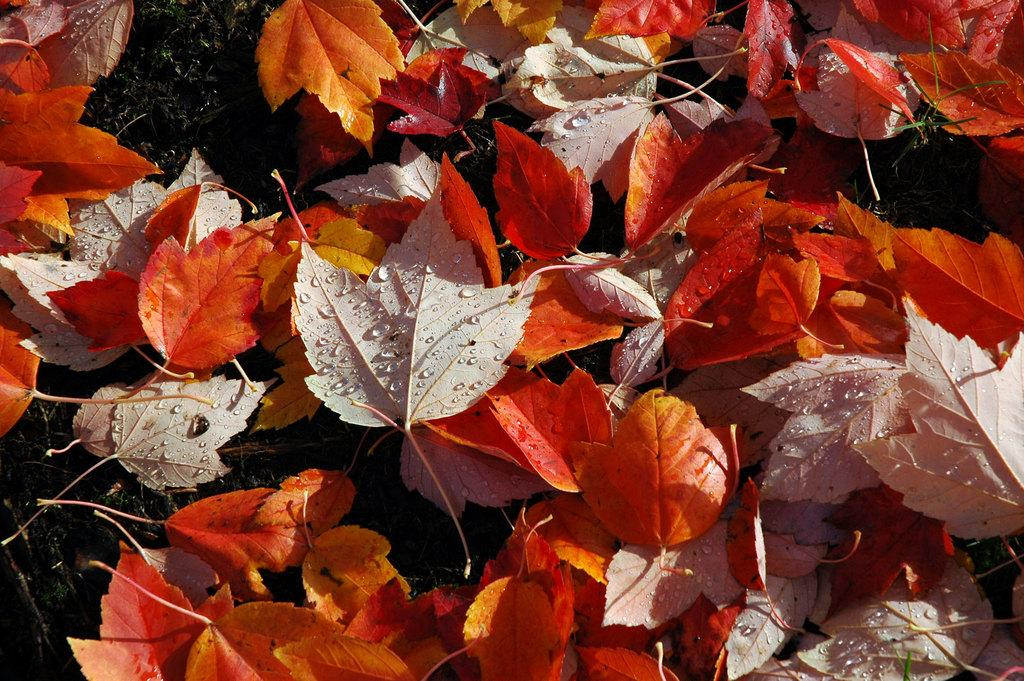What type of leaves can be seen in the image? There are autumn leaves in the image. Where are the leaves located in the image? The leaves are lying on the ground. What else can be seen in the image besides the leaves? There is grass visible in the image. What is the condition of the leaves in the image? Water drops are present on the leaves. Where is the parcel placed in the image? There is no parcel present in the image. What type of verse can be read from the leaves in the image? There is no verse present on the leaves in the image. 